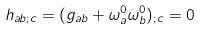<formula> <loc_0><loc_0><loc_500><loc_500>h _ { a b ; c } = ( g _ { a b } + \omega ^ { 0 } _ { a } \omega ^ { 0 } _ { b } ) _ { ; c } = 0</formula> 